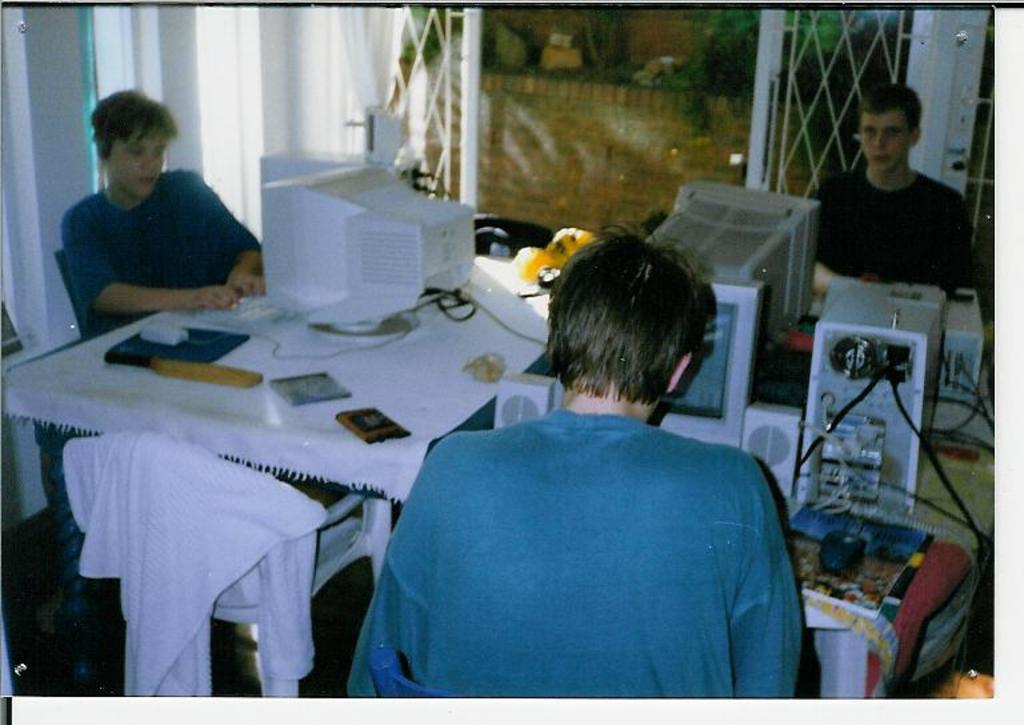How many people are in the image? There are three persons in the image. What electronic device is present in the image? There is a computer in the image. What is used to interact with the computer? There is a mouse in the image. What reading material is visible in the image? There is a book in the image. What type of object is present that connects the computer to another device? There is a wire in the image. What is covering the table in the image? The table is covered with a white cloth. What type of natural elements can be seen in the background of the image? There are plants visible in the background of the image. What type of game is being played by the maid in the image? There is no maid present in the image, and no game is being played. 